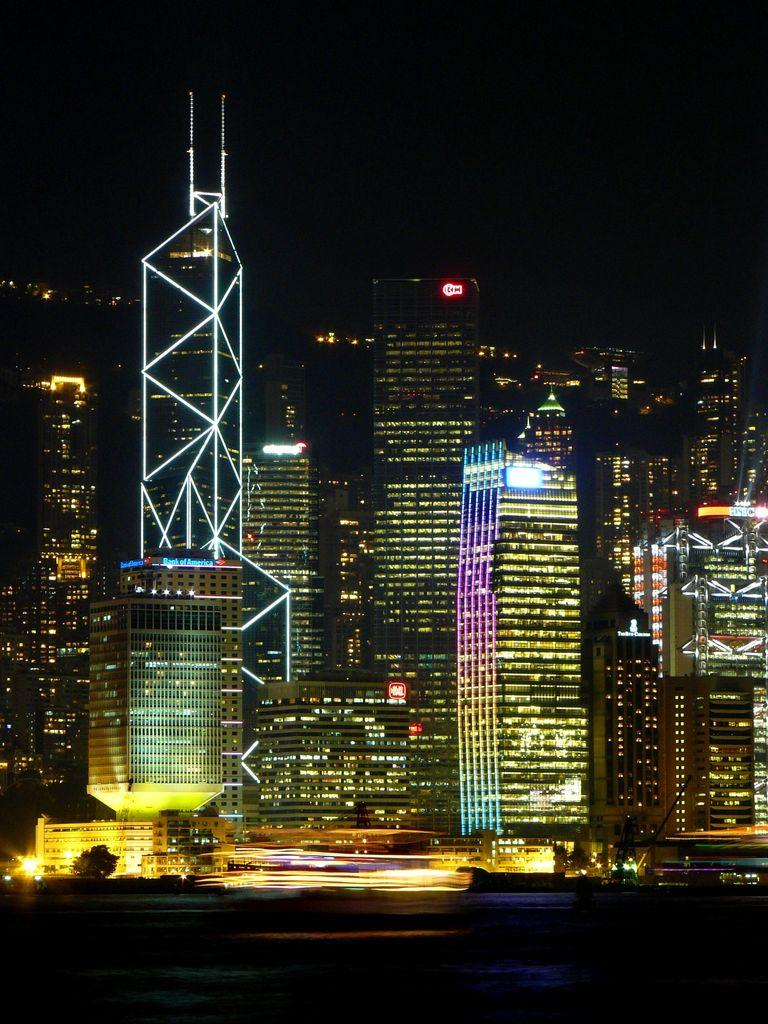What type of structures are present in the image? There is a group of buildings in the image. What features can be observed on the buildings? The buildings have windows and lights. Is there any additional information on one of the buildings? Yes, there is a signboard on one of the buildings. What other elements can be seen in the image? There are trees and a fence in the image. What can be seen in the background of the image? The sky is visible in the image. What color is the stomach of the plant in the image? There is no plant with a stomach present in the image, as plants do not have stomachs. 